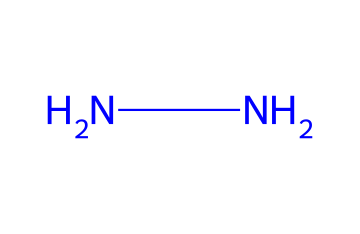What is the number of nitrogen atoms in hydrazine? The SMILES representation 'NN' shows two nitrogen (N) atoms connected to each other. Each letter 'N' denotes one nitrogen atom.
Answer: 2 How many bonds are present in the hydrazine molecule? The SMILES 'NN' indicates a single bond between the two nitrogen atoms. In this case, there is only one bond.
Answer: 1 What is the molecular formula of hydrazine? The chemical structure represented by 'NN' consists of two nitrogen atoms, and since there are no hydrogen or other atoms present in the depiction, the molecular formula is N2H4.
Answer: N2H4 Is hydrazine a symmetrical molecule? The structure 'NN' shows that the molecule is linear with equal nitrogen atoms on both sides, which indicates symmetry.
Answer: Yes What type of chemical bonds are present in hydrazine? The SMILES representation indicates that hydrazine contains covalent bonds between the nitrogen atoms, as they are directly bonded without any charged species or variations in electronegativity.
Answer: Covalent What are the primary uses of hydrazine in space exploration? Hydrazine is primarily used as a propellant in rocket fuels due to its high energy and ability to decompose rapidly into gases, providing thrust.
Answer: Propellant Is hydrazine classified as an oxidizer or a fuel? Hydrazine is classified as a fuel, as it primarily acts as a reducing agent in chemical reactions, often in conjunction with an oxidizer.
Answer: Fuel 